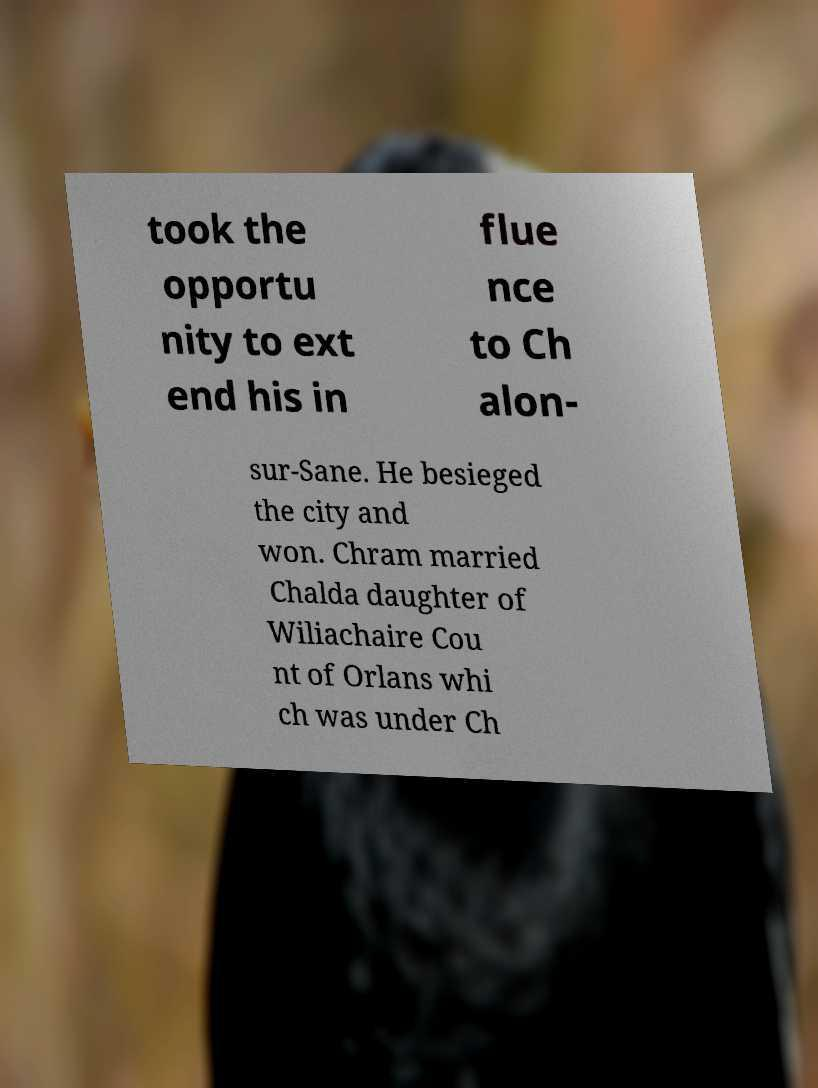Can you read and provide the text displayed in the image?This photo seems to have some interesting text. Can you extract and type it out for me? took the opportu nity to ext end his in flue nce to Ch alon- sur-Sane. He besieged the city and won. Chram married Chalda daughter of Wiliachaire Cou nt of Orlans whi ch was under Ch 